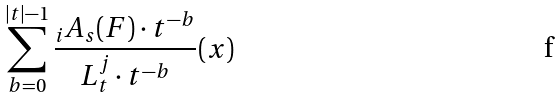<formula> <loc_0><loc_0><loc_500><loc_500>\sum _ { b = 0 } ^ { | t | - 1 } \frac { _ { i } A _ { s } ( F ) \cdot t ^ { - b } } { L _ { t } ^ { j } \cdot t ^ { - b } } ( x )</formula> 